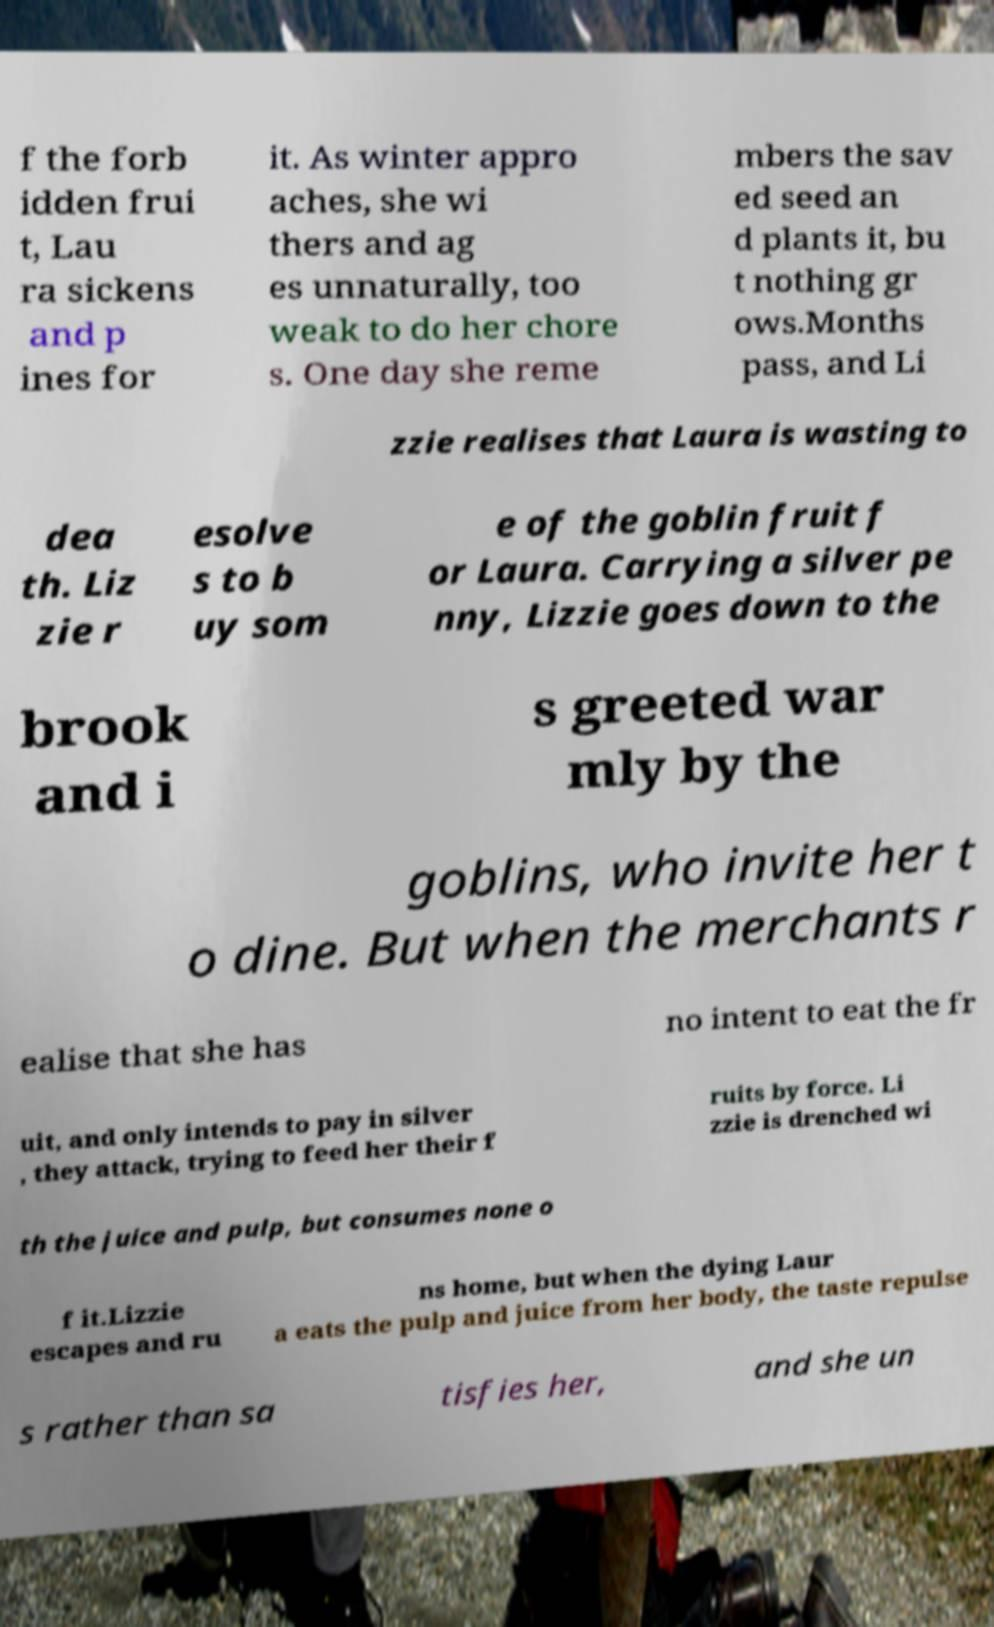Can you accurately transcribe the text from the provided image for me? f the forb idden frui t, Lau ra sickens and p ines for it. As winter appro aches, she wi thers and ag es unnaturally, too weak to do her chore s. One day she reme mbers the sav ed seed an d plants it, bu t nothing gr ows.Months pass, and Li zzie realises that Laura is wasting to dea th. Liz zie r esolve s to b uy som e of the goblin fruit f or Laura. Carrying a silver pe nny, Lizzie goes down to the brook and i s greeted war mly by the goblins, who invite her t o dine. But when the merchants r ealise that she has no intent to eat the fr uit, and only intends to pay in silver , they attack, trying to feed her their f ruits by force. Li zzie is drenched wi th the juice and pulp, but consumes none o f it.Lizzie escapes and ru ns home, but when the dying Laur a eats the pulp and juice from her body, the taste repulse s rather than sa tisfies her, and she un 